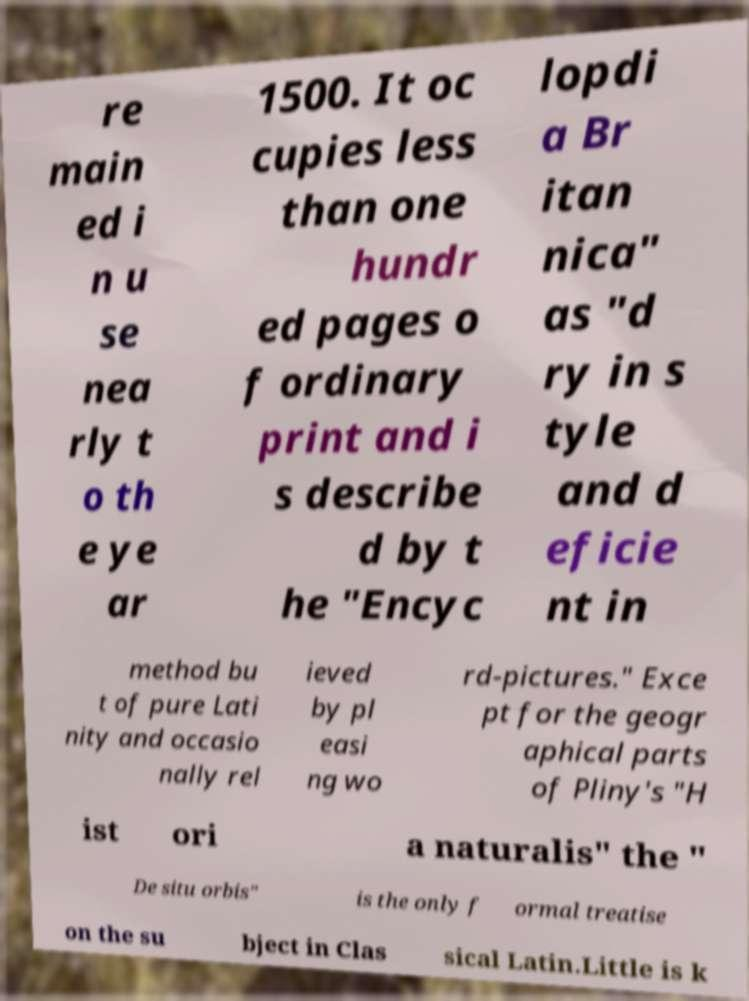There's text embedded in this image that I need extracted. Can you transcribe it verbatim? re main ed i n u se nea rly t o th e ye ar 1500. It oc cupies less than one hundr ed pages o f ordinary print and i s describe d by t he "Encyc lopdi a Br itan nica" as "d ry in s tyle and d eficie nt in method bu t of pure Lati nity and occasio nally rel ieved by pl easi ng wo rd-pictures." Exce pt for the geogr aphical parts of Pliny's "H ist ori a naturalis" the " De situ orbis" is the only f ormal treatise on the su bject in Clas sical Latin.Little is k 